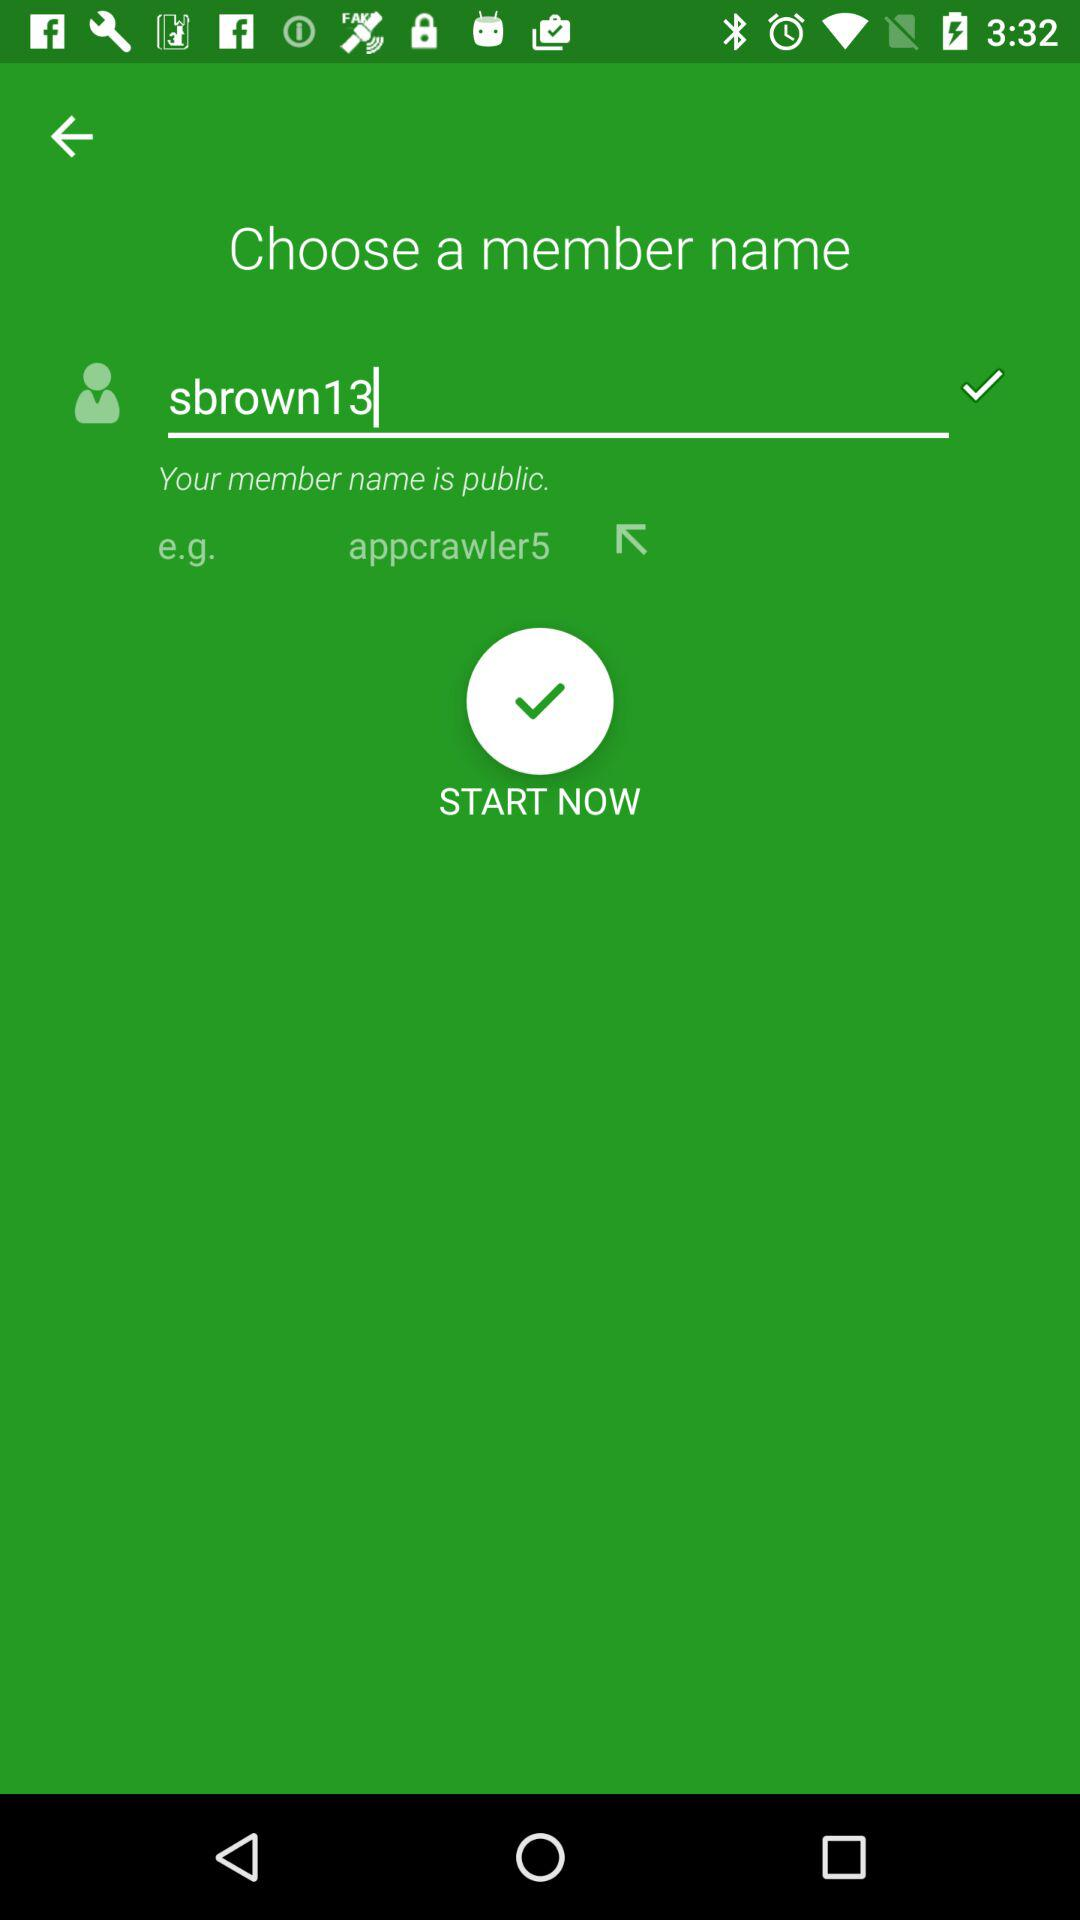What name is given in the example? The given name is "appcrawler5". 